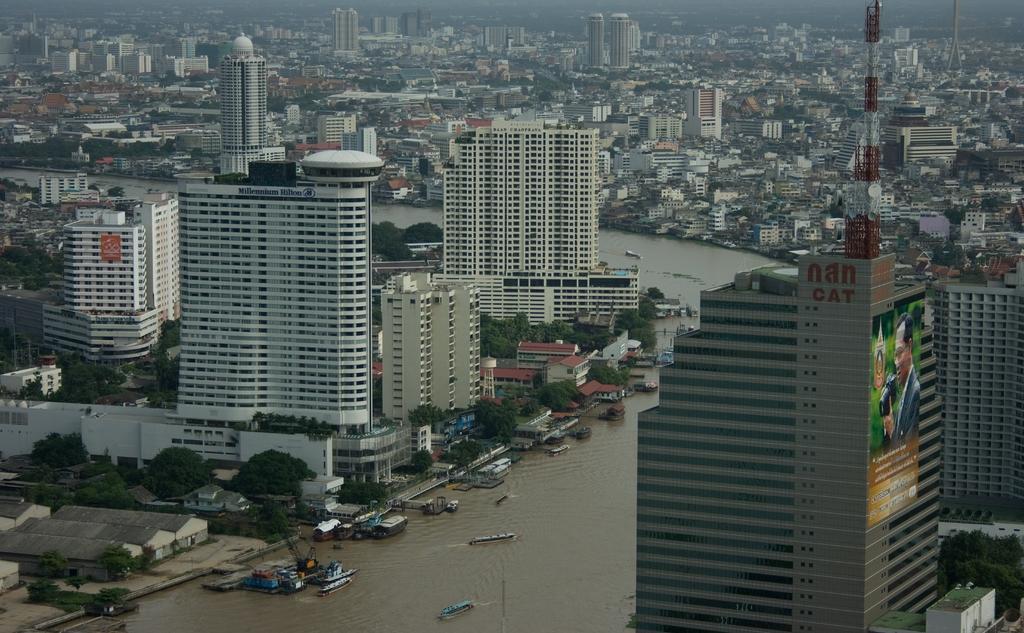In one or two sentences, can you explain what this image depicts? This is an aerial view. In this picture we can see the buildings, trees, houses, boats, water, polo, towers, boats, ground. At the top of the image we can see the sky. 